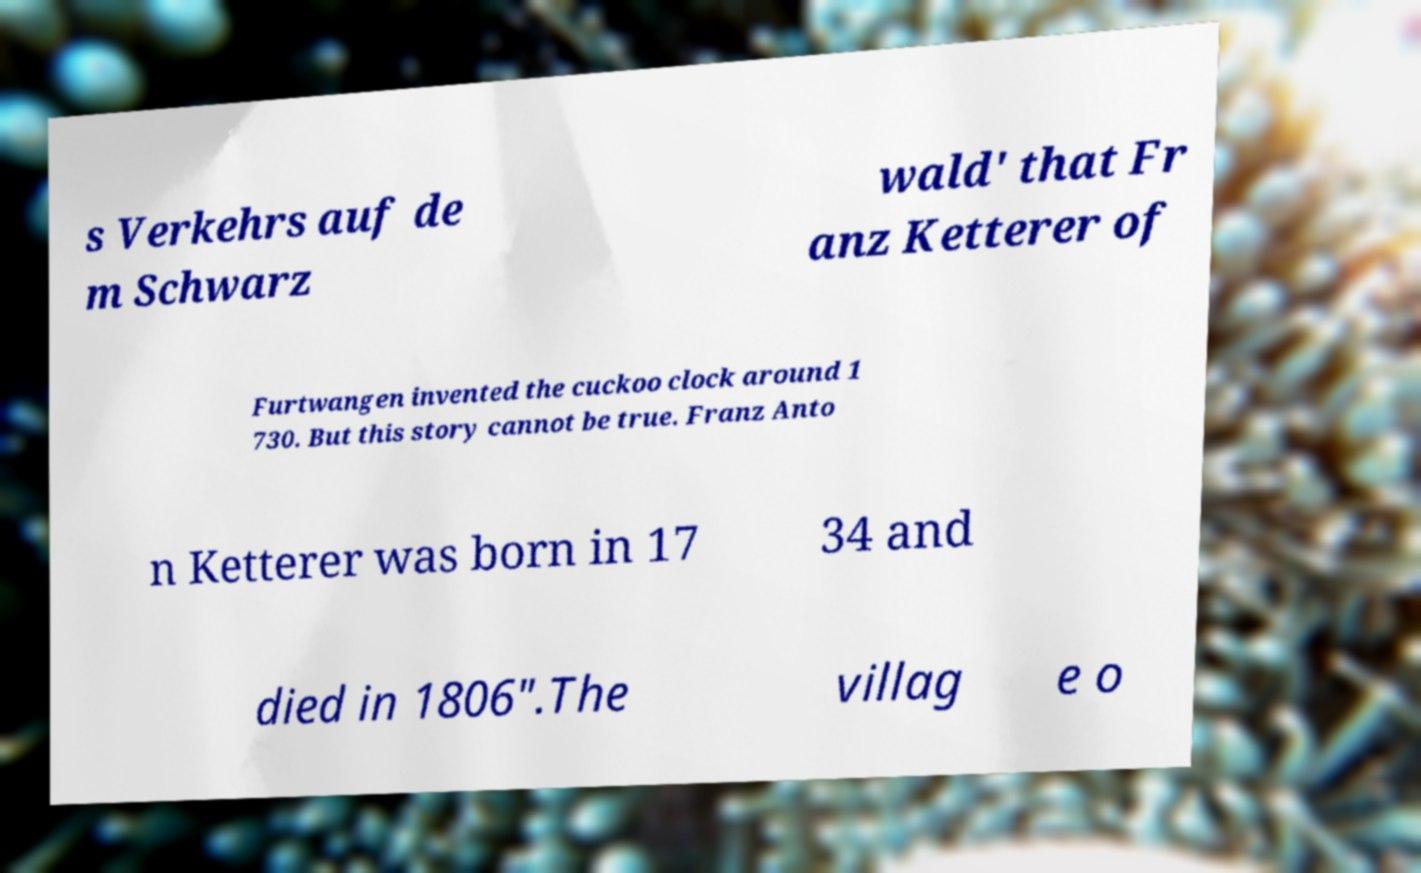I need the written content from this picture converted into text. Can you do that? s Verkehrs auf de m Schwarz wald' that Fr anz Ketterer of Furtwangen invented the cuckoo clock around 1 730. But this story cannot be true. Franz Anto n Ketterer was born in 17 34 and died in 1806".The villag e o 